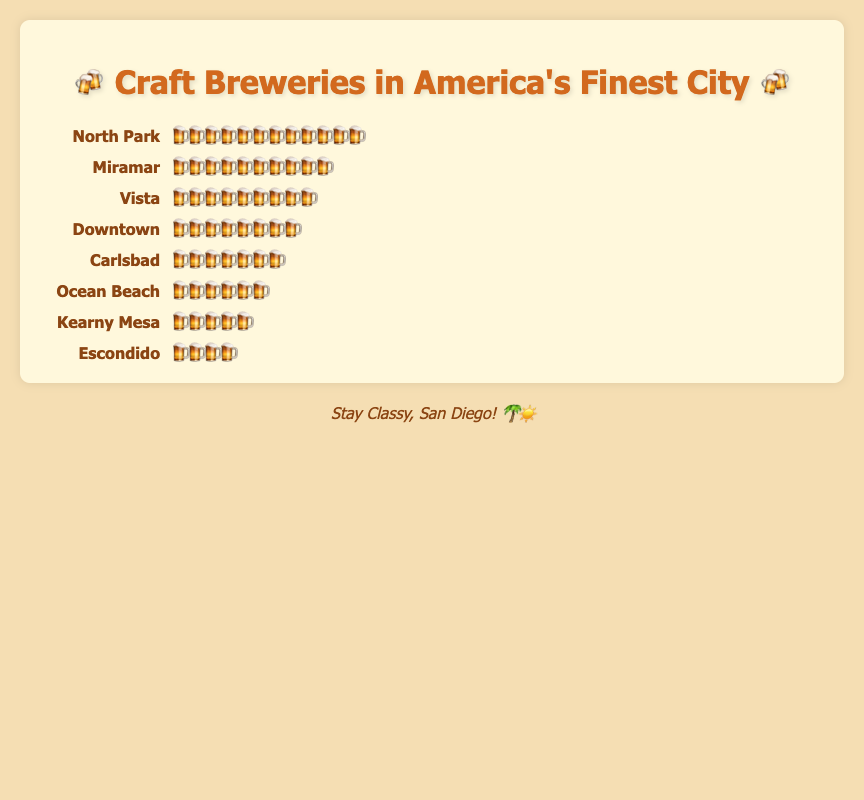Which neighborhood has the most craft breweries? North Park has 12 beer icons, which indicates the highest number of craft breweries.
Answer: North Park Which neighborhood has the least craft breweries? Escondido has the least with 4 beer icons.
Answer: Escondido How many craft breweries are there in Downtown? Count the number of beer icons next to Downtown, which is 8.
Answer: 8 What is the difference in the number of craft breweries between North Park and Escondido? North Park has 12 breweries, and Escondido has 4. So, 12 - 4 = 8.
Answer: 8 Which neighborhoods have more than 7 craft breweries? North Park (12), Miramar (10), Downtown (8), and Vista (9) all have more than 7 breweries.
Answer: North Park, Miramar, Downtown, Vista How many total craft breweries are there in the listed neighborhoods? Sum all the icons: 12 (North Park) + 10 (Miramar) + 6 (Ocean Beach) + 8 (Downtown) + 5 (Kearny Mesa) + 7 (Carlsbad) + 4 (Escondido) + 9 (Vista) = 61.
Answer: 61 Which neighborhood has exactly one more craft brewery than Carlsbad? Carlsbad has 7 breweries. Vista has one more with 9 - 1 = 8 breweries.
Answer: Vista How many neighborhoods have fewer than 6 craft breweries? Ocean Beach (6), Kearny Mesa (5), and Escondido (4) each have fewer than 6 breweries, which totals to 3 neighborhoods.
Answer: 3 What's the average number of craft breweries per neighborhood? Total number of breweries is 61. There are 8 neighborhoods. So, the average is 61 / 8 ≈ 7.625.
Answer: 7.625 Which neighborhood has twice as many craft breweries as another neighborhood? Miramar has 10 breweries and Kearny Mesa has 5, so Miramar has twice as many as Kearny Mesa.
Answer: Miramar and Kearny Mesa 